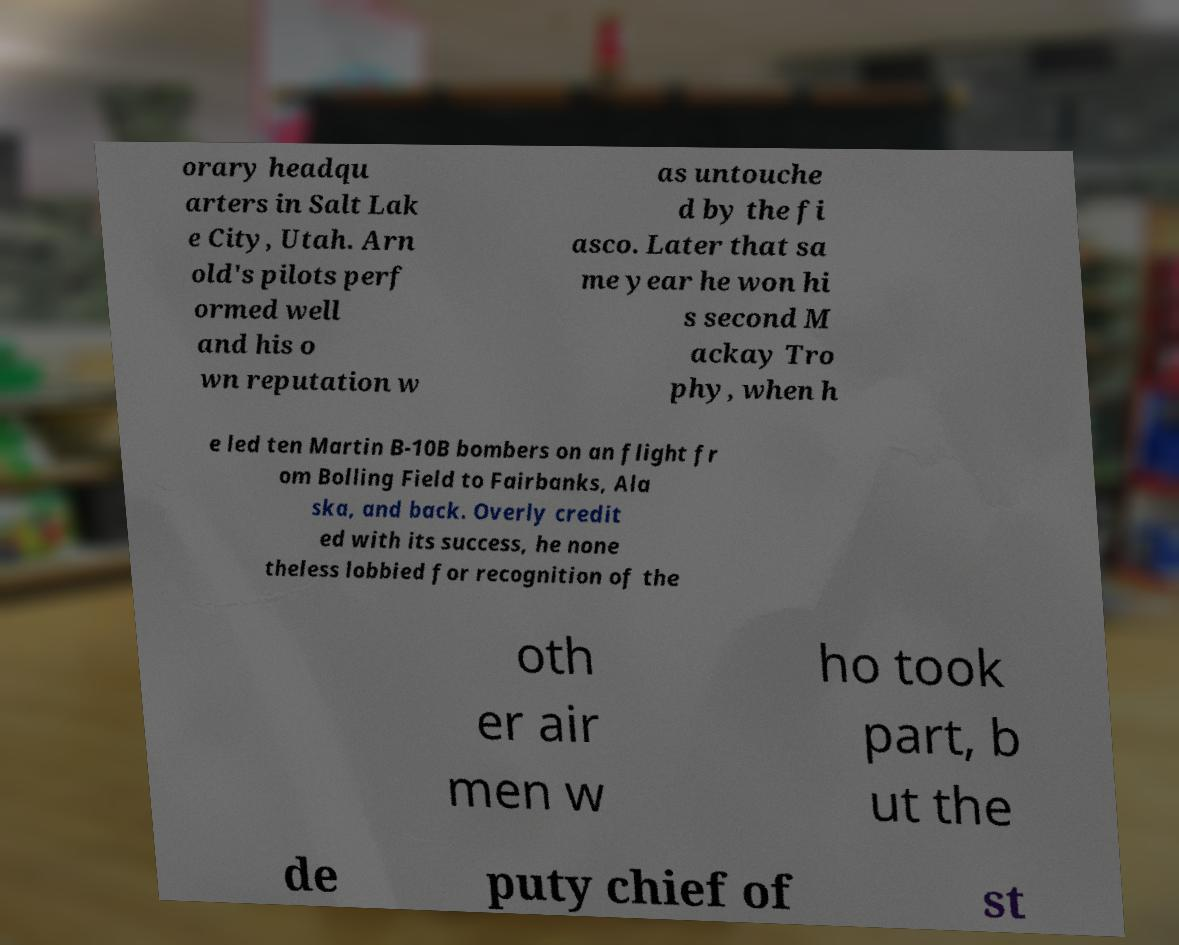Please read and relay the text visible in this image. What does it say? orary headqu arters in Salt Lak e City, Utah. Arn old's pilots perf ormed well and his o wn reputation w as untouche d by the fi asco. Later that sa me year he won hi s second M ackay Tro phy, when h e led ten Martin B-10B bombers on an flight fr om Bolling Field to Fairbanks, Ala ska, and back. Overly credit ed with its success, he none theless lobbied for recognition of the oth er air men w ho took part, b ut the de puty chief of st 